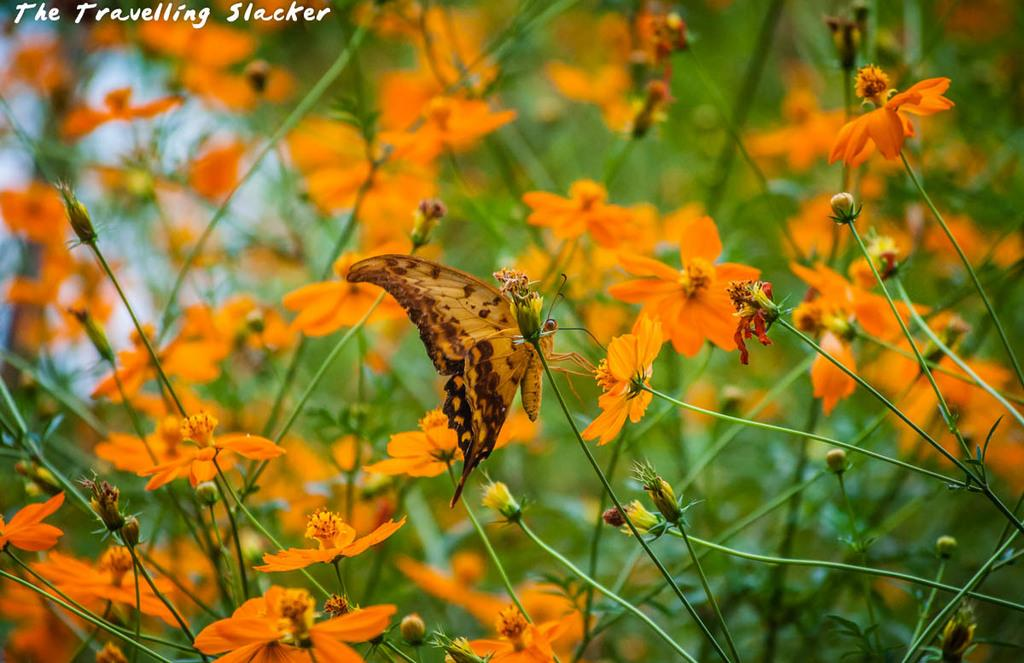What type of animal can be seen in the image? There is a butterfly in the image. What other living organisms are present in the image? There are flowers in the image. How would you describe the background of the image? The background of the image is blurred. Is there any text or logo visible in the image? Yes, there is a watermark in the top left corner of the image. How many stores can be seen in the image? There are no stores present in the image. What color is the butterfly in the image? The color of the butterfly cannot be determined from the image, as it is not in color. 